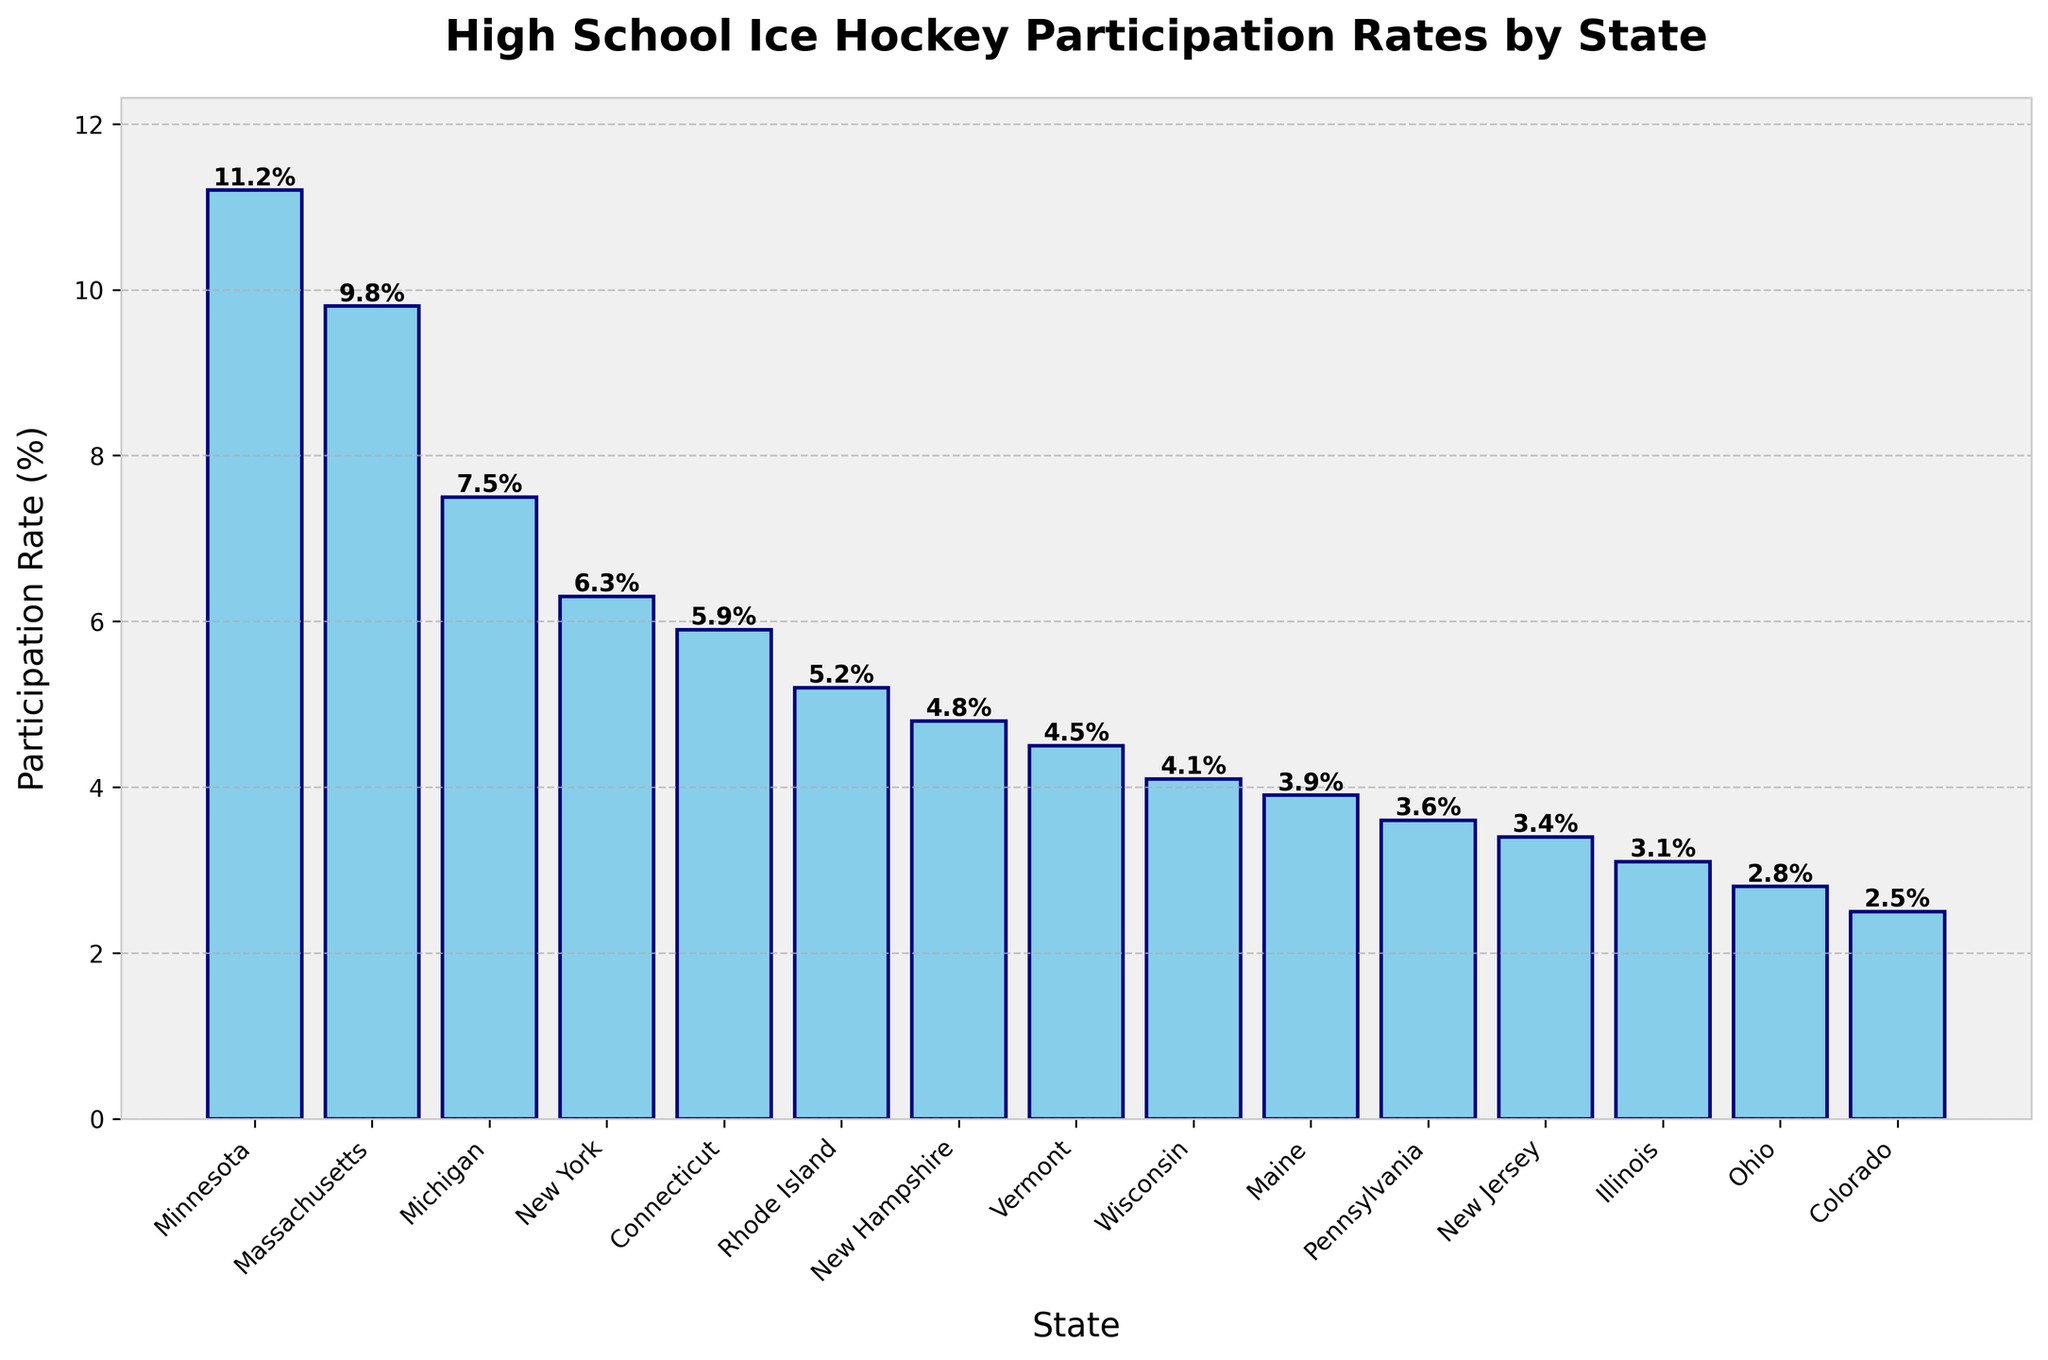What's the state with the highest high school ice hockey participation rate? The figure shows a bar chart of participation rates across different states. By visually identifying the tallest bar, you can determine that Minnesota has the highest participation rate.
Answer: Minnesota Which state has a higher participation rate, Ohio or Illinois? By comparing the height of the bars representing Ohio and Illinois, you can see that the bar for Illinois is taller, indicating a higher participation rate.
Answer: Illinois What is the difference in participation rates between Massachusetts and Michigan? The bar chart lists Massachusetts at 9.8% and Michigan at 7.5%. Subtracting the participation rate of Michigan from Massachusetts (9.8 - 7.5 = 2.3) gives the difference.
Answer: 2.3% Which states have participation rates greater than 5% but less than 10%? The states that have bars within these range bounds are Massachusetts, Michigan, New York, Connecticut, and Rhode Island.
Answer: Massachusetts, Michigan, New York, Connecticut, Rhode Island What's the combined participation rate of Minnesota, Wisconsin, and Ohio? Adding the participation rates of Minnesota (11.2%), Wisconsin (4.1%), and Ohio (2.8%) gives 11.2 + 4.1 + 2.8 = 18.1%.
Answer: 18.1% How many states have a participation rate below 4%? By counting the bars ending below the 4% mark, you find that Maine (3.9%), Pennsylvania (3.6%), New Jersey (3.4%), Illinois (3.1%), and Ohio (2.8%) have rates below 4%. There are 5 states total.
Answer: 5 Which state has the smallest high school ice hockey participation rate? Observing the bar chart, identifying the shortest bar reveals that Colorado has the smallest participation rate at 2.5%.
Answer: Colorado How many states are shown in the bar chart? Counting the total number of bars representing different states gives a count of 15 states.
Answer: 15 What's the median participation rate among the states shown? The sorted list of participation rates is: [2.5, 2.8, 3.1, 3.4, 3.6, 3.9, 4.1, 4.5, 4.8, 5.2, 5.9, 6.3, 7.5, 9.8, 11.2]. The median value, being the middle element in this ordered list, is 4.8%.
Answer: 4.8% 